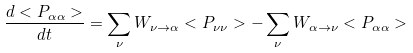<formula> <loc_0><loc_0><loc_500><loc_500>\frac { d < P _ { \alpha \alpha } > } { d t } = \sum _ { \nu } W _ { \nu \rightarrow \alpha } < P _ { \nu \nu } > - \sum _ { \nu } W _ { \alpha \rightarrow \nu } < P _ { \alpha \alpha } ></formula> 